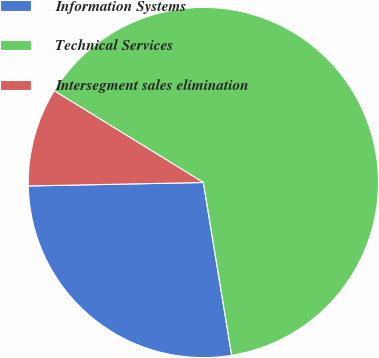Convert chart. <chart><loc_0><loc_0><loc_500><loc_500><pie_chart><fcel>Information Systems<fcel>Technical Services<fcel>Intersegment sales elimination<nl><fcel>27.27%<fcel>63.64%<fcel>9.09%<nl></chart> 